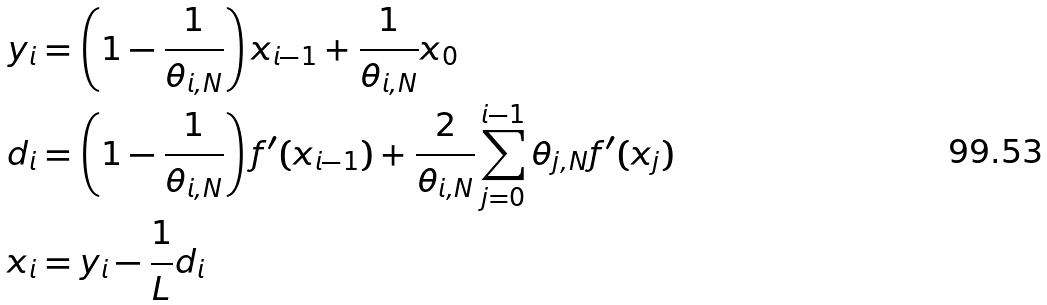<formula> <loc_0><loc_0><loc_500><loc_500>y _ { i } & = \left ( 1 - \frac { 1 } { \theta _ { i , N } } \right ) x _ { i - 1 } + \frac { 1 } { \theta _ { i , N } } x _ { 0 } \\ d _ { i } & = \left ( 1 - \frac { 1 } { \theta _ { i , N } } \right ) f ^ { \prime } ( x _ { i - 1 } ) + \frac { 2 } { \theta _ { i , N } } \sum _ { j = 0 } ^ { i - 1 } \theta _ { j , N } f ^ { \prime } ( x _ { j } ) \\ x _ { i } & = y _ { i } - \frac { 1 } { L } d _ { i }</formula> 